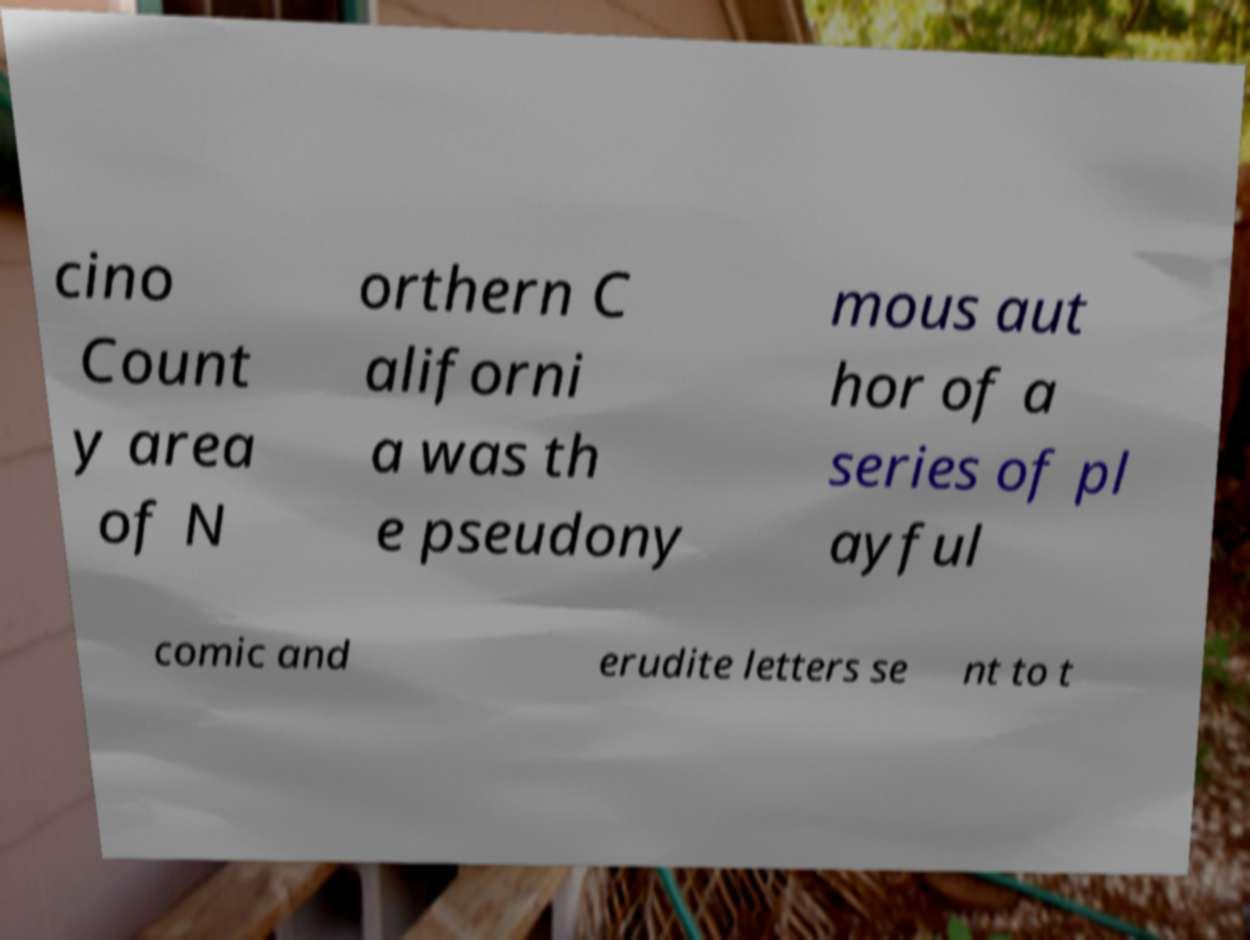Could you extract and type out the text from this image? cino Count y area of N orthern C aliforni a was th e pseudony mous aut hor of a series of pl ayful comic and erudite letters se nt to t 